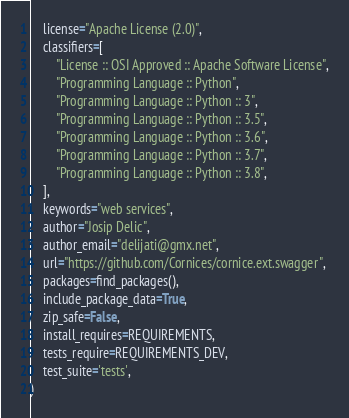<code> <loc_0><loc_0><loc_500><loc_500><_Python_>    license="Apache License (2.0)",
    classifiers=[
        "License :: OSI Approved :: Apache Software License",
        "Programming Language :: Python",
        "Programming Language :: Python :: 3",
        "Programming Language :: Python :: 3.5",
        "Programming Language :: Python :: 3.6",
        "Programming Language :: Python :: 3.7",
        "Programming Language :: Python :: 3.8",
    ],
    keywords="web services",
    author="Josip Delic",
    author_email="delijati@gmx.net",
    url="https://github.com/Cornices/cornice.ext.swagger",
    packages=find_packages(),
    include_package_data=True,
    zip_safe=False,
    install_requires=REQUIREMENTS,
    tests_require=REQUIREMENTS_DEV,
    test_suite='tests',
)
</code> 